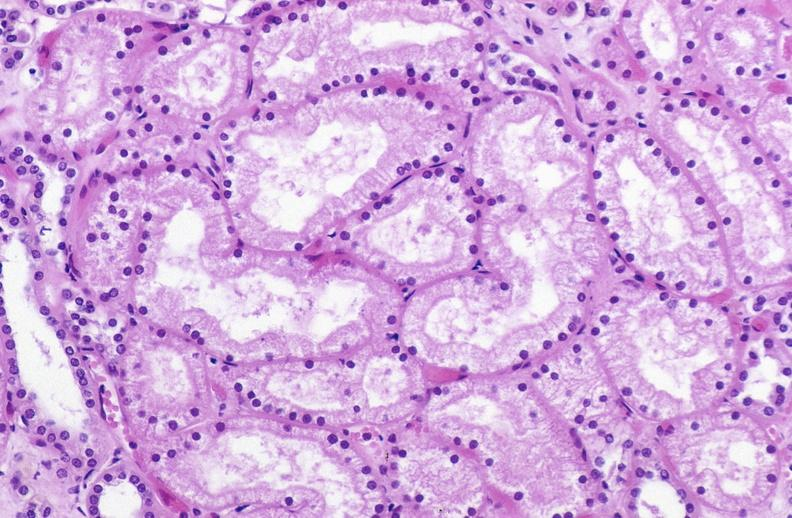where is this?
Answer the question using a single word or phrase. Urinary 